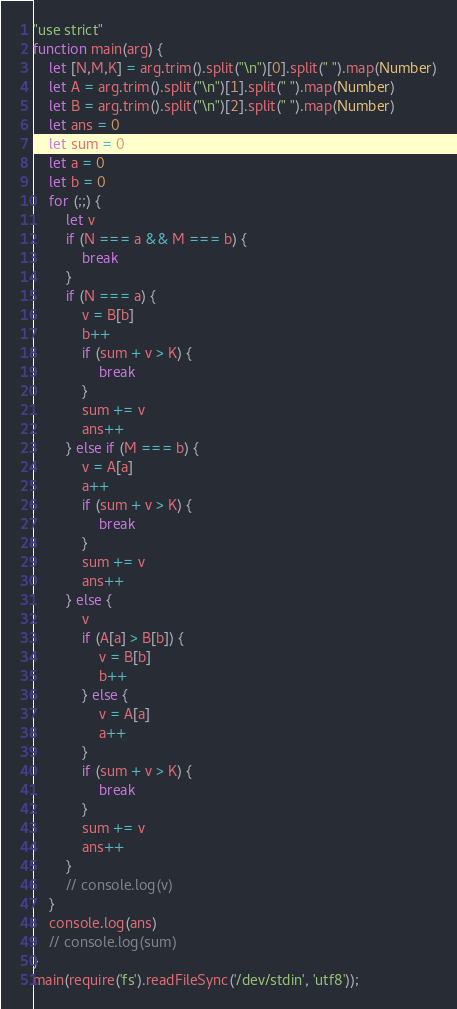<code> <loc_0><loc_0><loc_500><loc_500><_JavaScript_>"use strict"
function main(arg) {
    let [N,M,K] = arg.trim().split("\n")[0].split(" ").map(Number)
    let A = arg.trim().split("\n")[1].split(" ").map(Number)
    let B = arg.trim().split("\n")[2].split(" ").map(Number)
    let ans = 0
    let sum = 0
    let a = 0
    let b = 0
    for (;;) {
        let v
        if (N === a && M === b) {
            break
        }
        if (N === a) {
            v = B[b]
            b++
            if (sum + v > K) {
                break
            }
            sum += v
            ans++
        } else if (M === b) {
            v = A[a]
            a++
            if (sum + v > K) {
                break
            }
            sum += v
            ans++
        } else {
            v
            if (A[a] > B[b]) {
                v = B[b]
                b++
            } else {
                v = A[a]
                a++
            }
            if (sum + v > K) {
                break
            }
            sum += v
            ans++
        }
        // console.log(v)
    }
    console.log(ans)
    // console.log(sum)
}
main(require('fs').readFileSync('/dev/stdin', 'utf8'));</code> 